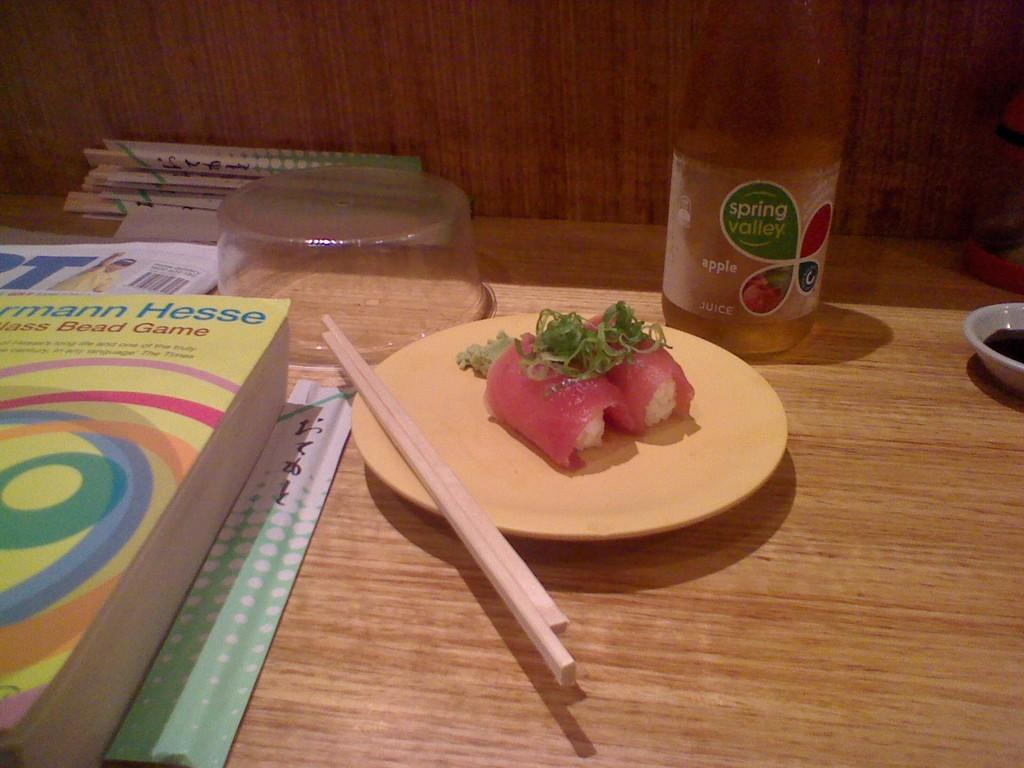What type of furniture is present in the image? There is a table in the image. What is on the table? There is a saucer on the table, which contains food. What utensils are on the table? There are chopsticks on the table. What else can be found on the table? There is a bottle, bowls, a book, and a newspaper on the table. What other objects are on the table? There are sticks on the table. Is there a volcano erupting in the image? No, there is no volcano present in the image. What type of polish is being applied to the table in the image? There is no polish or any indication of polishing in the image. 